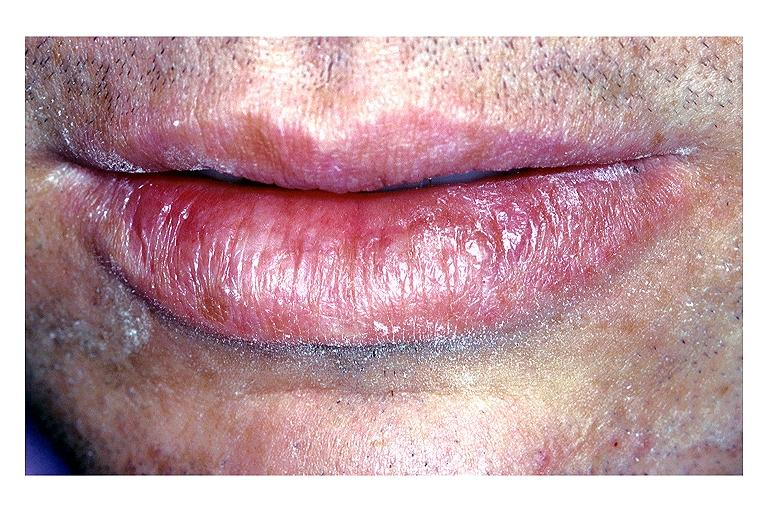where is this?
Answer the question using a single word or phrase. Oral 